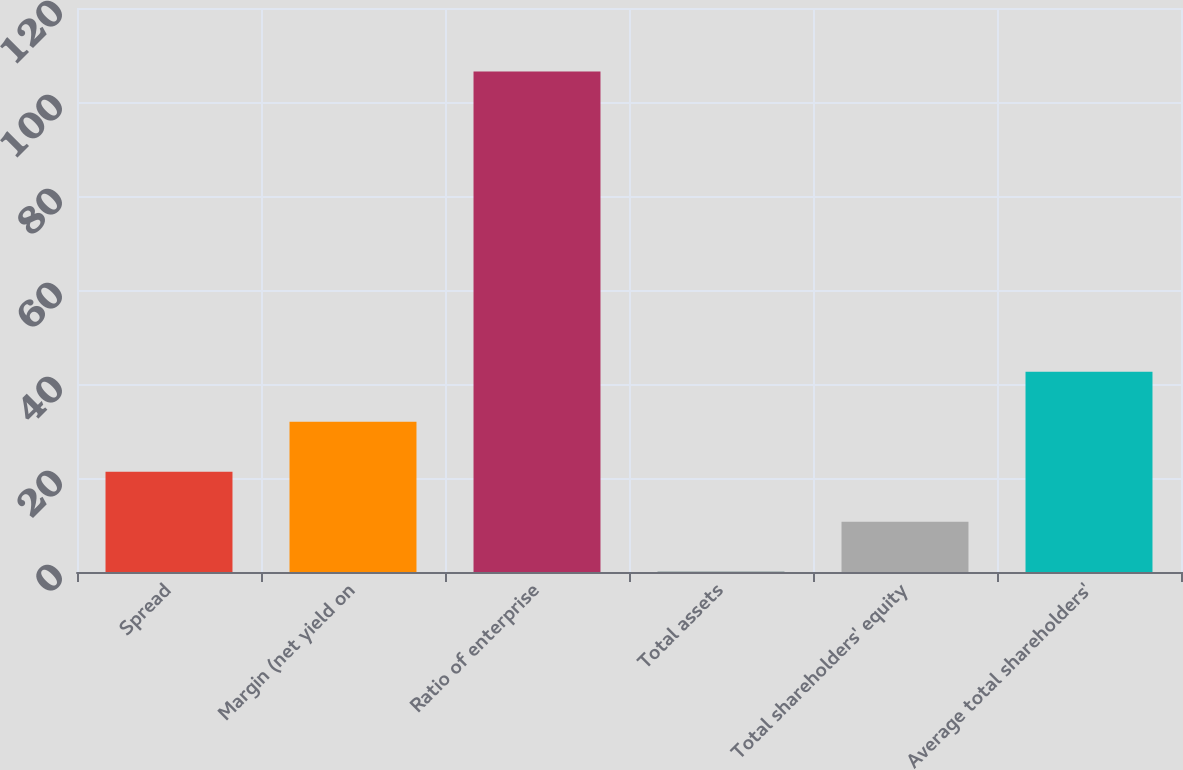<chart> <loc_0><loc_0><loc_500><loc_500><bar_chart><fcel>Spread<fcel>Margin (net yield on<fcel>Ratio of enterprise<fcel>Total assets<fcel>Total shareholders' equity<fcel>Average total shareholders'<nl><fcel>21.34<fcel>31.98<fcel>106.49<fcel>0.06<fcel>10.7<fcel>42.62<nl></chart> 